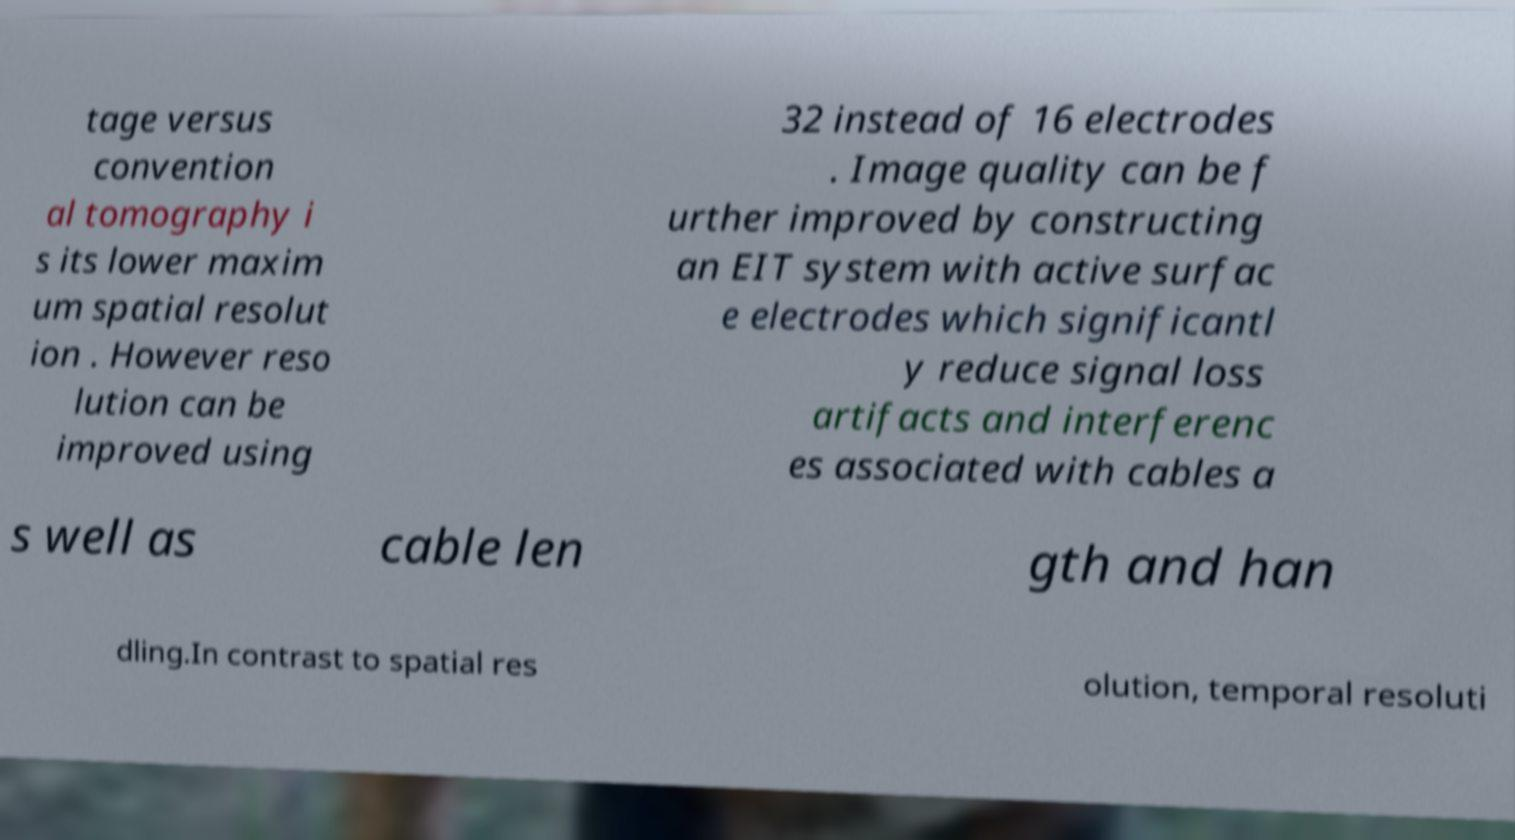Can you read and provide the text displayed in the image?This photo seems to have some interesting text. Can you extract and type it out for me? tage versus convention al tomography i s its lower maxim um spatial resolut ion . However reso lution can be improved using 32 instead of 16 electrodes . Image quality can be f urther improved by constructing an EIT system with active surfac e electrodes which significantl y reduce signal loss artifacts and interferenc es associated with cables a s well as cable len gth and han dling.In contrast to spatial res olution, temporal resoluti 